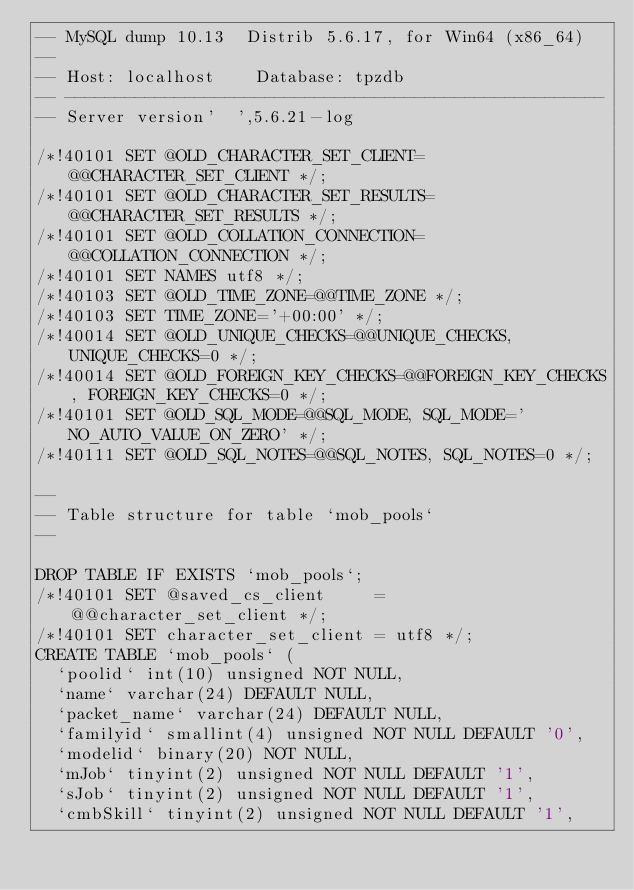<code> <loc_0><loc_0><loc_500><loc_500><_SQL_>-- MySQL dump 10.13  Distrib 5.6.17, for Win64 (x86_64)
--
-- Host: localhost    Database: tpzdb
-- ------------------------------------------------------
-- Server version'  ',5.6.21-log

/*!40101 SET @OLD_CHARACTER_SET_CLIENT=@@CHARACTER_SET_CLIENT */;
/*!40101 SET @OLD_CHARACTER_SET_RESULTS=@@CHARACTER_SET_RESULTS */;
/*!40101 SET @OLD_COLLATION_CONNECTION=@@COLLATION_CONNECTION */;
/*!40101 SET NAMES utf8 */;
/*!40103 SET @OLD_TIME_ZONE=@@TIME_ZONE */;
/*!40103 SET TIME_ZONE='+00:00' */;
/*!40014 SET @OLD_UNIQUE_CHECKS=@@UNIQUE_CHECKS, UNIQUE_CHECKS=0 */;
/*!40014 SET @OLD_FOREIGN_KEY_CHECKS=@@FOREIGN_KEY_CHECKS, FOREIGN_KEY_CHECKS=0 */;
/*!40101 SET @OLD_SQL_MODE=@@SQL_MODE, SQL_MODE='NO_AUTO_VALUE_ON_ZERO' */;
/*!40111 SET @OLD_SQL_NOTES=@@SQL_NOTES, SQL_NOTES=0 */;

--
-- Table structure for table `mob_pools`
--

DROP TABLE IF EXISTS `mob_pools`;
/*!40101 SET @saved_cs_client     = @@character_set_client */;
/*!40101 SET character_set_client = utf8 */;
CREATE TABLE `mob_pools` (
  `poolid` int(10) unsigned NOT NULL,
  `name` varchar(24) DEFAULT NULL,
  `packet_name` varchar(24) DEFAULT NULL,
  `familyid` smallint(4) unsigned NOT NULL DEFAULT '0',
  `modelid` binary(20) NOT NULL,
  `mJob` tinyint(2) unsigned NOT NULL DEFAULT '1',
  `sJob` tinyint(2) unsigned NOT NULL DEFAULT '1',
  `cmbSkill` tinyint(2) unsigned NOT NULL DEFAULT '1',</code> 